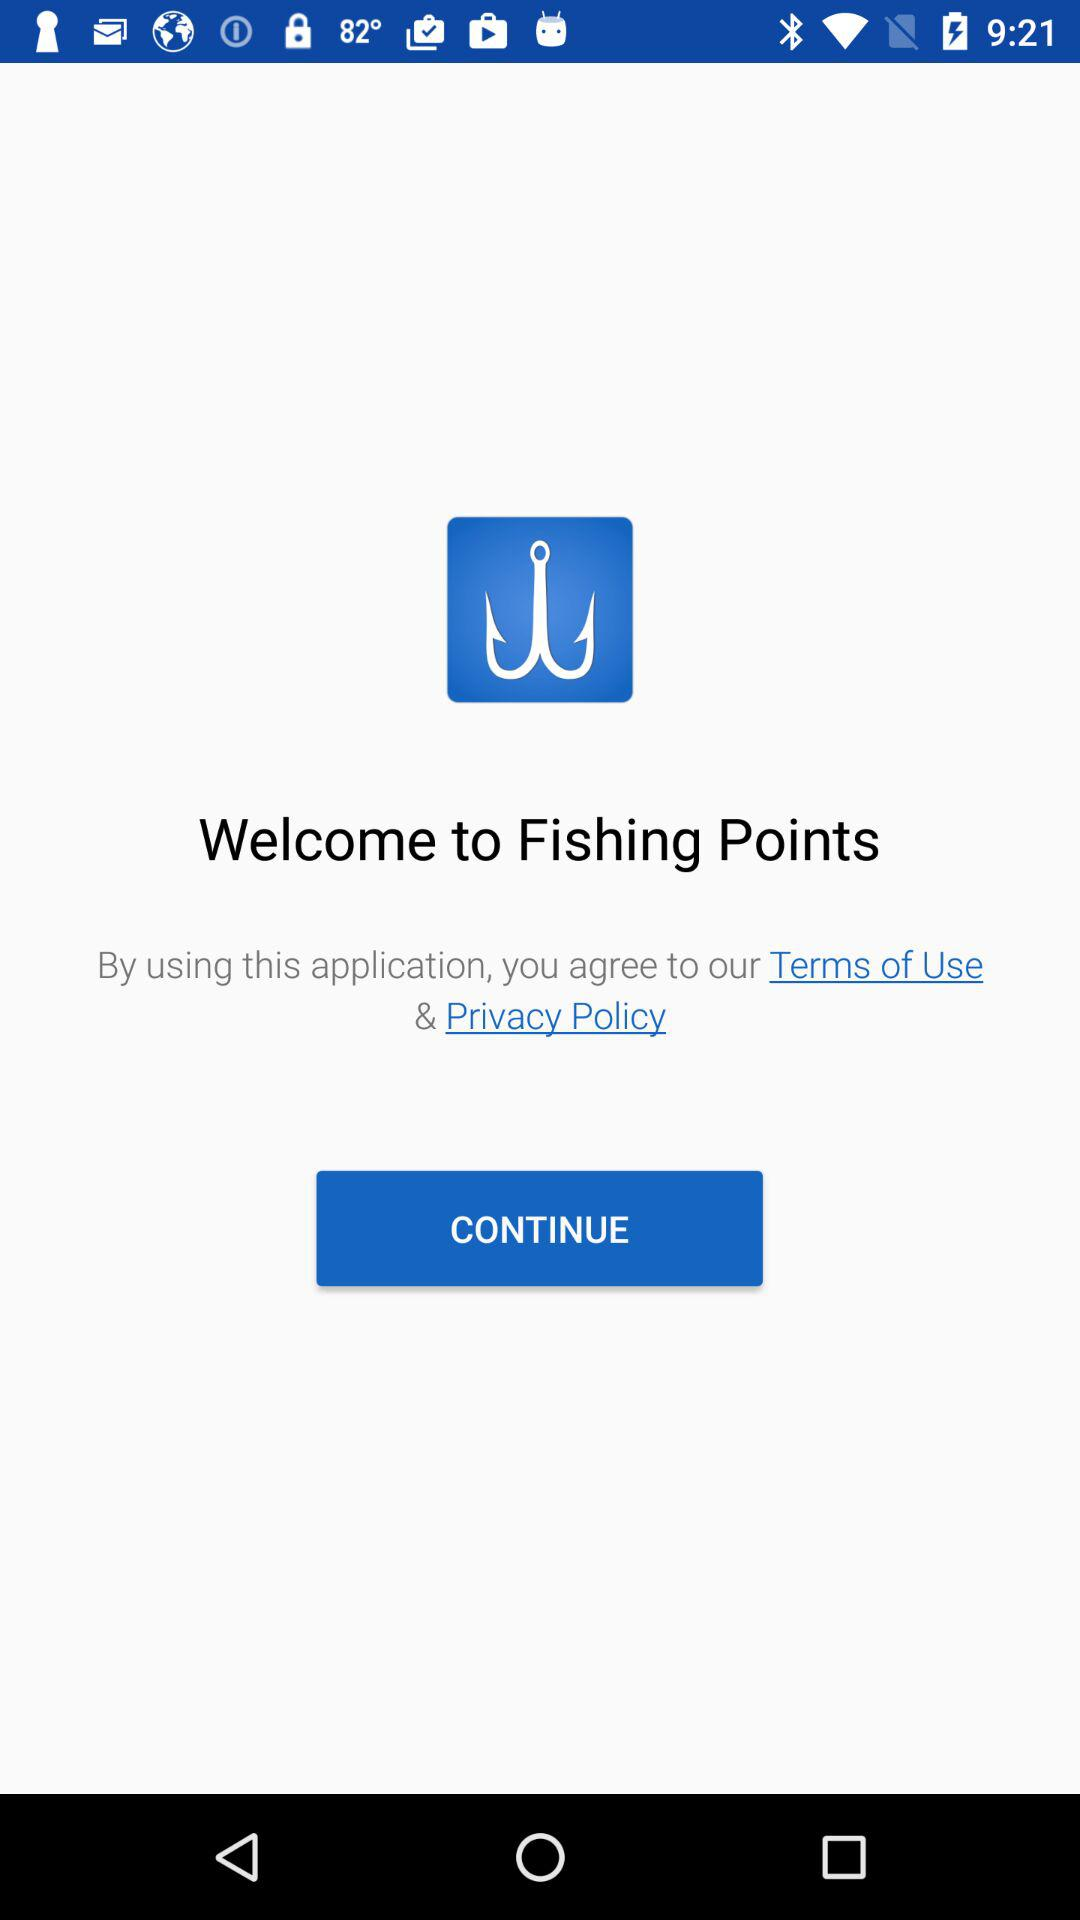What is the name of the application? The name of the application is "Fishing Points". 